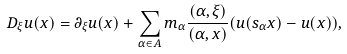<formula> <loc_0><loc_0><loc_500><loc_500>D _ { \xi } u ( x ) = \partial _ { \xi } u ( x ) + \sum _ { \alpha \in A } m _ { \alpha } \frac { ( \alpha , \xi ) } { ( \alpha , x ) } ( u ( s _ { \alpha } x ) - u ( x ) ) ,</formula> 